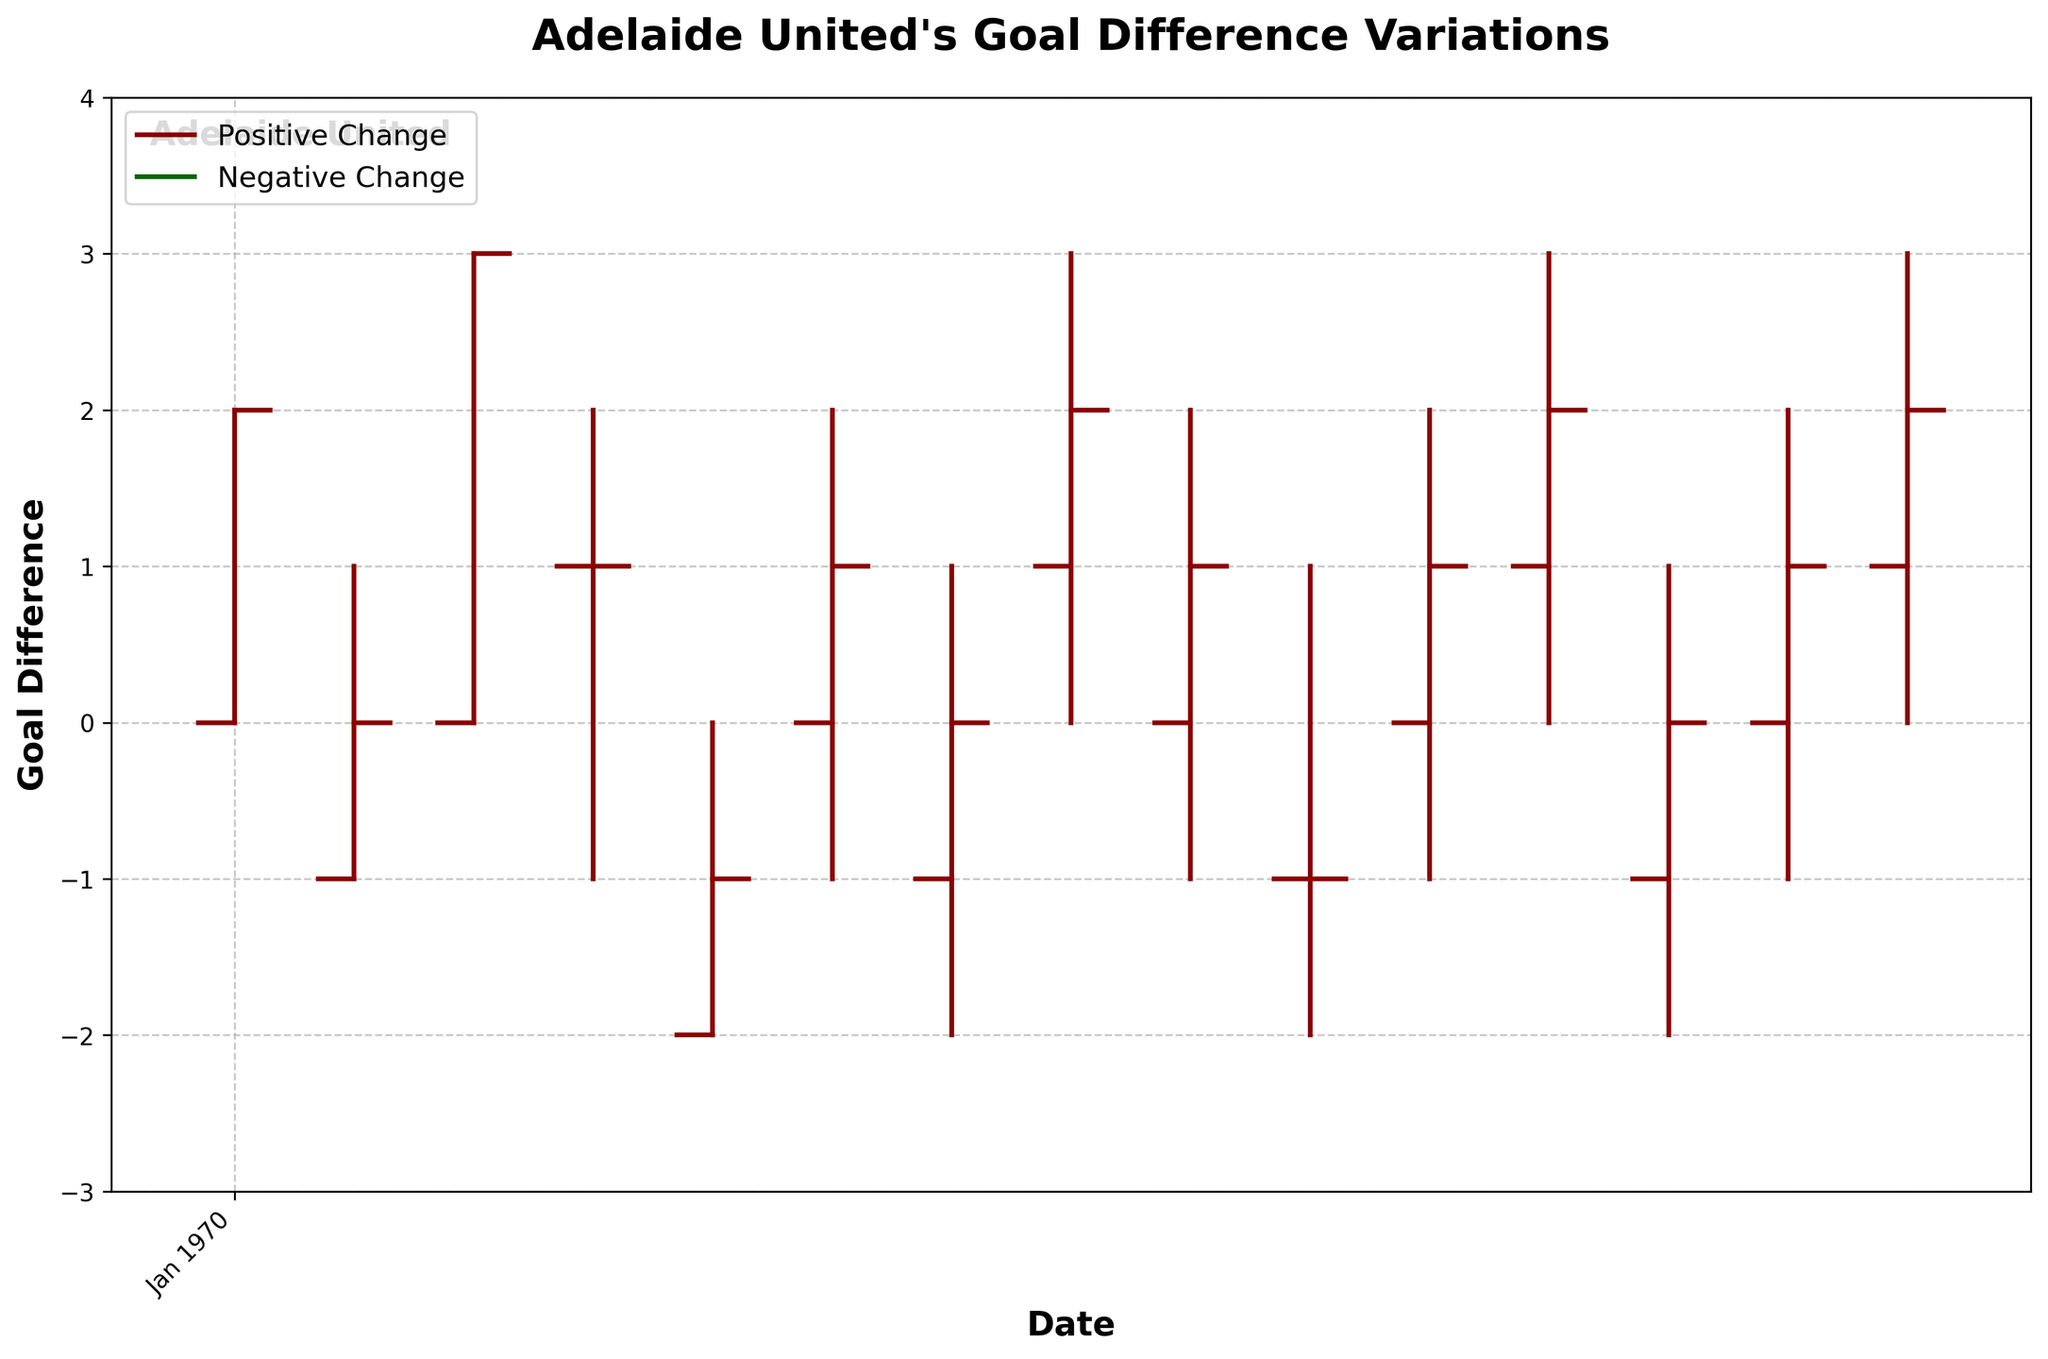What's the title of the plot? The title is located at the top-center of the plot and usually describes the main focus. Here, it says "Adelaide United's Goal Difference Variations."
Answer: Adelaide United's Goal Difference Variations Over which months does the data span? The x-axis labels display the time range of the data points. The data spans from October 2022 to April 2023.
Answer: October 2022 to April 2023 How many times did Adelaide United's goal difference stay the same (Open and Close values equal)? Looking at the OHLC bars, compare the 'Open' and 'Close' values. If they are equal, the goal difference stayed the same. This happens 2 times (2022-10-15 and 2022-11-12).
Answer: 2 Which month had the highest positive goal difference? Check the 'High' values on the y-axis and look at the dates to identify which month had the highest value. November 2022 had the highest positive goal difference of 3.
Answer: November 2022 During which months did the team experience a negative goal difference (Close < Open)? Identify the goal difference where the Close value is less than the Open value. It happened in December 2022 and February 2023.
Answer: December 2022 and February 2023 What is the overall trend in Adelaide United's goal differences from October 2022 to April 2023? Observing the OHLC bars' overall pattern helps identify the trend. Generally, there seems to be a fluctuating but slightly increasing trend.
Answer: Fluctuating but slightly increasing What is the lowest recorded goal difference, and in which month did it occur? Check the 'Low' values on the y-axis and correlate them with the dates. The lowest recorded goal difference was -2, occurring in December 2022, January 2023, February 2023, and April 2023.
Answer: -2 in December 2022, January 2023, February 2023, and April 2023 Compare the goal difference between October 2022 and April 2023. Which month had a higher closing goal difference? Refer to the 'Close' values for the months of October 2022 and April 2023. October 2022 had a closing goal difference of 2, while April 2023 had a closing goal difference of 2 as well. They are equal.
Answer: They are equal How many times did the goal difference go negative (Close < 0)? Check the 'Close' values and count the number of times they are below 0. The goal difference went negative 3 times.
Answer: 3 What was the highest goal difference recorded, irrespective of whether it was an open, high, low, or close value, and in which month did it occur? Examine all the 'High' values. The highest goal difference was 3, occurring in November 2022, January 2023, March 2023, and April 2023.
Answer: 3 in November 2022, January 2023, March 2023, and April 2023 